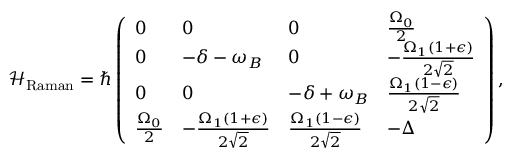Convert formula to latex. <formula><loc_0><loc_0><loc_500><loc_500>\mathcal { H } _ { R a m a n } = \hbar { \left } ( \begin{array} { l l l l } { 0 } & { 0 } & { 0 } & { \frac { \Omega _ { 0 } } { 2 } } \\ { 0 } & { - \delta - \omega _ { B } } & { 0 } & { - \frac { \Omega _ { 1 } ( 1 + \epsilon ) } { 2 \sqrt { 2 } } } \\ { 0 } & { 0 } & { - \delta + \omega _ { B } } & { \frac { \Omega _ { 1 } ( 1 - \epsilon ) } { 2 \sqrt { 2 } } } \\ { \frac { \Omega _ { 0 } } { 2 } } & { - \frac { \Omega _ { 1 } ( 1 + \epsilon ) } { 2 \sqrt { 2 } } } & { \frac { \Omega _ { 1 } ( 1 - \epsilon ) } { 2 \sqrt { 2 } } } & { - \Delta } \end{array} \right ) ,</formula> 